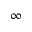Convert formula to latex. <formula><loc_0><loc_0><loc_500><loc_500>\infty</formula> 